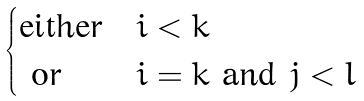<formula> <loc_0><loc_0><loc_500><loc_500>\begin{cases} \text {either} & i < k \\ \text { or } & i = k \text { and } j < l \end{cases}</formula> 